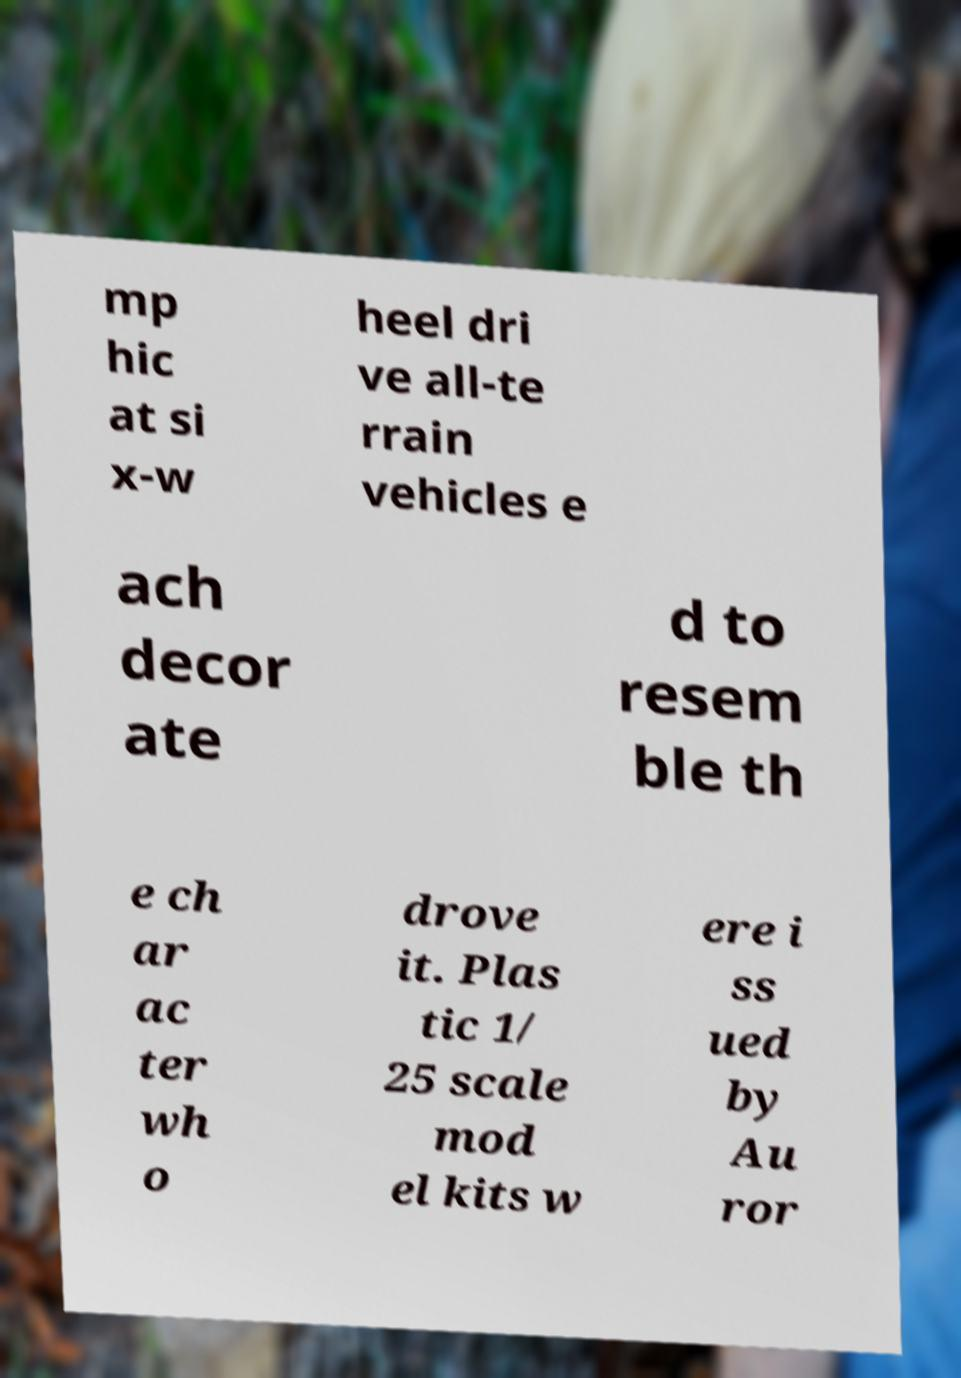Please identify and transcribe the text found in this image. mp hic at si x-w heel dri ve all-te rrain vehicles e ach decor ate d to resem ble th e ch ar ac ter wh o drove it. Plas tic 1/ 25 scale mod el kits w ere i ss ued by Au ror 